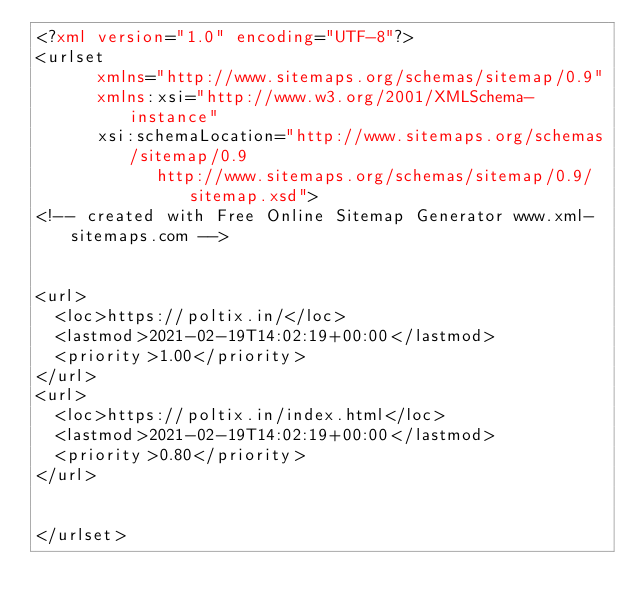Convert code to text. <code><loc_0><loc_0><loc_500><loc_500><_XML_><?xml version="1.0" encoding="UTF-8"?>
<urlset
      xmlns="http://www.sitemaps.org/schemas/sitemap/0.9"
      xmlns:xsi="http://www.w3.org/2001/XMLSchema-instance"
      xsi:schemaLocation="http://www.sitemaps.org/schemas/sitemap/0.9
            http://www.sitemaps.org/schemas/sitemap/0.9/sitemap.xsd">
<!-- created with Free Online Sitemap Generator www.xml-sitemaps.com -->


<url>
  <loc>https://poltix.in/</loc>
  <lastmod>2021-02-19T14:02:19+00:00</lastmod>
  <priority>1.00</priority>
</url>
<url>
  <loc>https://poltix.in/index.html</loc>
  <lastmod>2021-02-19T14:02:19+00:00</lastmod>
  <priority>0.80</priority>
</url>


</urlset></code> 